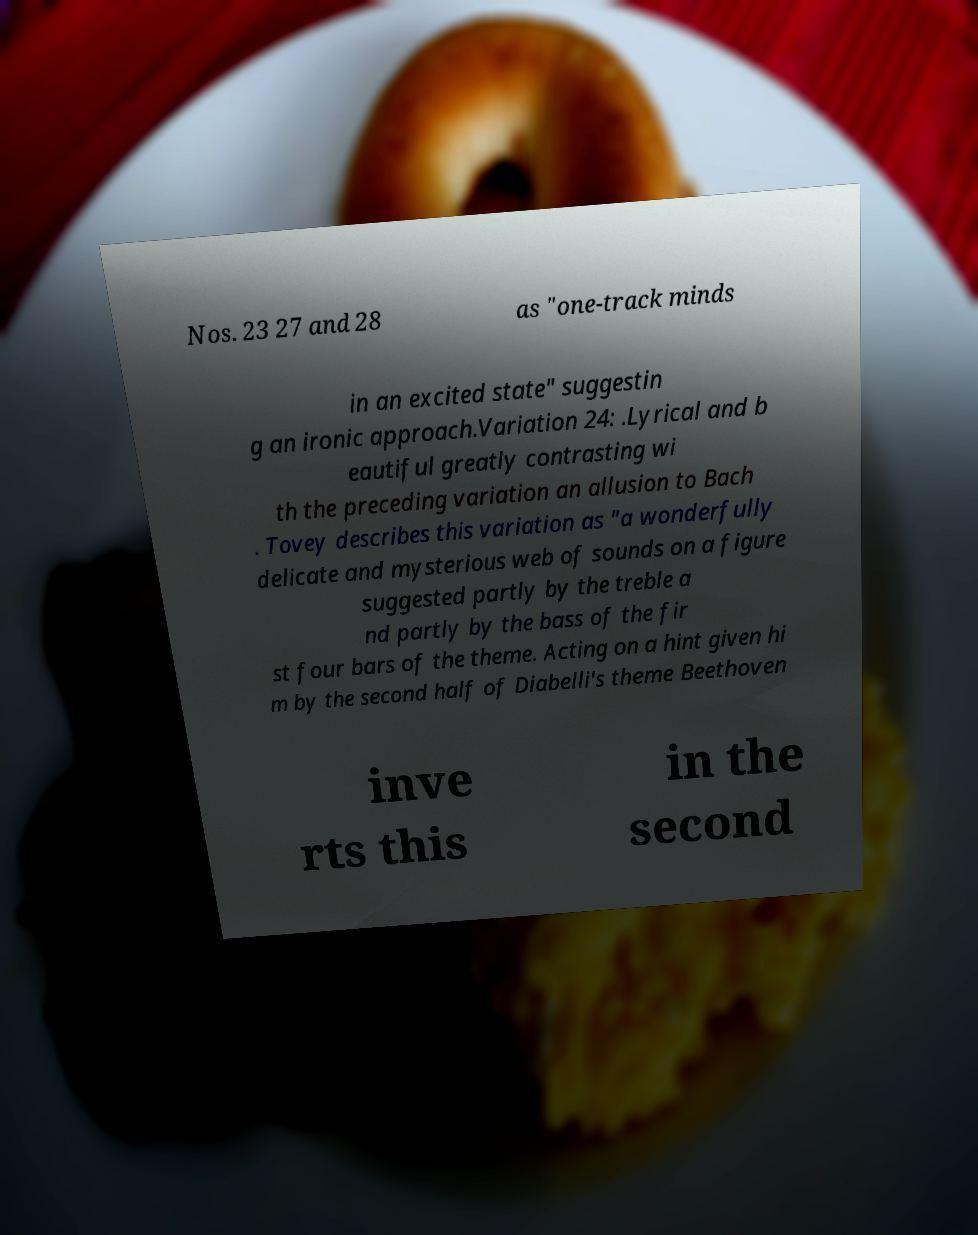I need the written content from this picture converted into text. Can you do that? Nos. 23 27 and 28 as "one-track minds in an excited state" suggestin g an ironic approach.Variation 24: .Lyrical and b eautiful greatly contrasting wi th the preceding variation an allusion to Bach . Tovey describes this variation as "a wonderfully delicate and mysterious web of sounds on a figure suggested partly by the treble a nd partly by the bass of the fir st four bars of the theme. Acting on a hint given hi m by the second half of Diabelli's theme Beethoven inve rts this in the second 